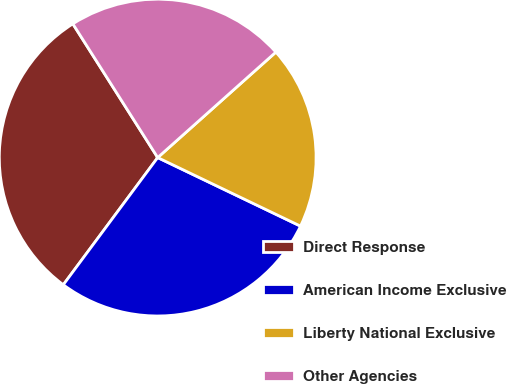Convert chart to OTSL. <chart><loc_0><loc_0><loc_500><loc_500><pie_chart><fcel>Direct Response<fcel>American Income Exclusive<fcel>Liberty National Exclusive<fcel>Other Agencies<nl><fcel>30.84%<fcel>28.04%<fcel>18.72%<fcel>22.4%<nl></chart> 